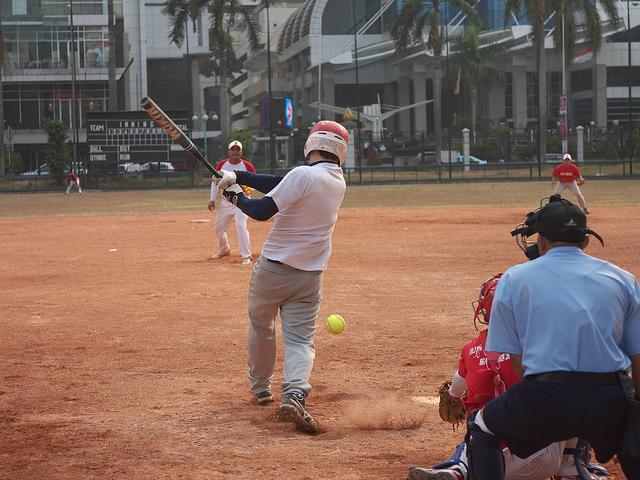What word is printed on the bat?
Write a very short answer. Worth. Is it a strike?
Write a very short answer. Yes. Who is winning the game?
Answer briefly. Red team. What color is the ball?
Quick response, please. Yellow. What are the young men doing in the photo?
Short answer required. Playing baseball. What pitch was thrown?
Concise answer only. First. Did the batter hit the ball?
Concise answer only. No. What color is the catcher's gear?
Keep it brief. Red. Did he hit the ball?
Answer briefly. No. Did the batter get a strike?
Write a very short answer. Yes. Is this a Little League game?
Keep it brief. No. Has the batter swung the bat yet?
Keep it brief. Yes. 